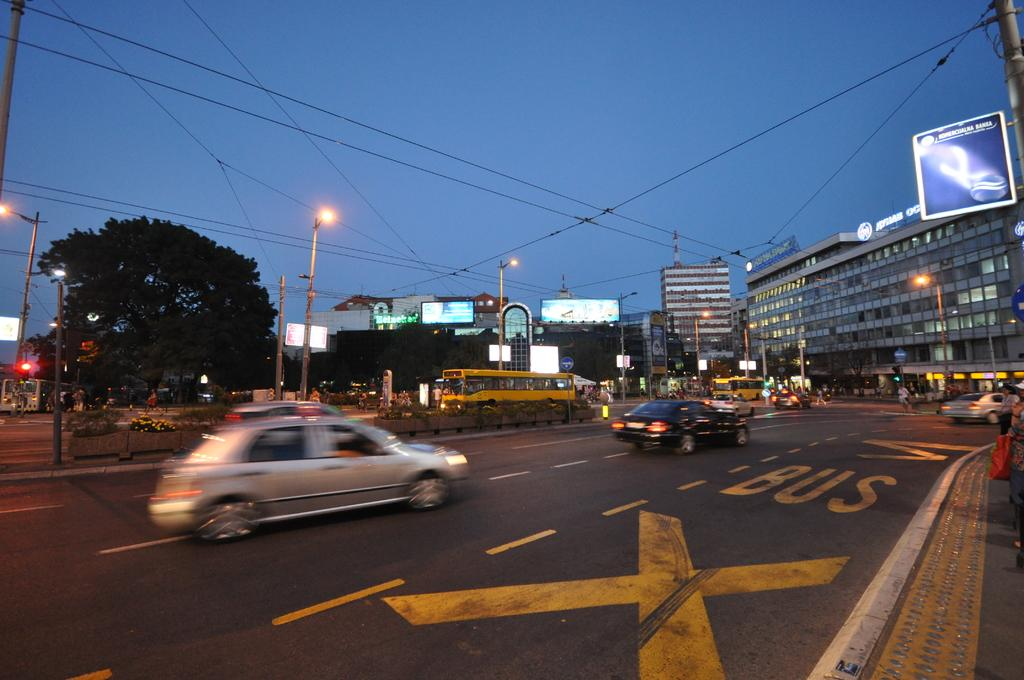<image>
Describe the image concisely. Cars are driving down a road that says Bus on the far right lane. 